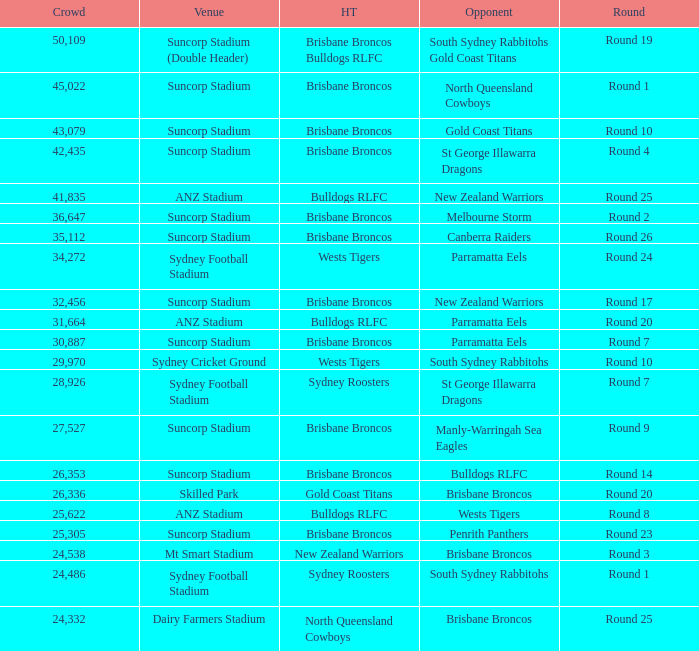What was the attendance at Round 9? 1.0. 